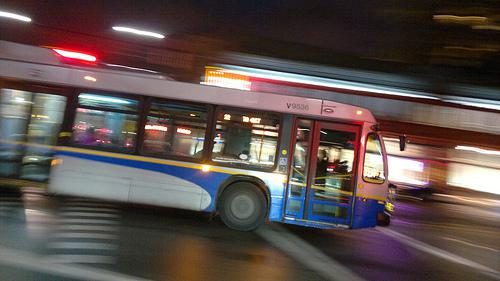Question: what is in the photo?
Choices:
A. A bus.
B. A truck.
C. A van.
D. A jeep.
Answer with the letter. Answer: A Question: where was the photo taken?
Choices:
A. An avenue.
B. A boulevard.
C. A road.
D. A street.
Answer with the letter. Answer: D Question: when was the photo taken?
Choices:
A. Day.
B. At midnight.
C. Early morning.
D. Nighttime.
Answer with the letter. Answer: D Question: what are shining?
Choices:
A. Stars.
B. Lights.
C. Sequins.
D. Diamonds.
Answer with the letter. Answer: B 